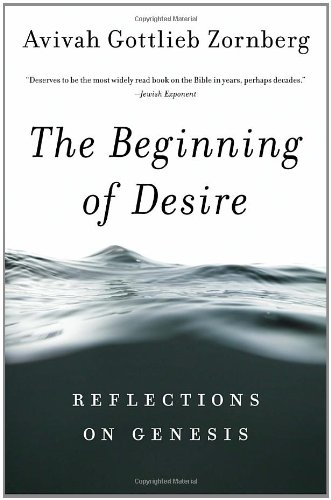What philosophical themes does the book explore in relation to Genesis? The book delves into themes such as human desire, moral complexities, and the quest for spiritual meaning, each deeply rooted in the biblical narratives of Genesis. 